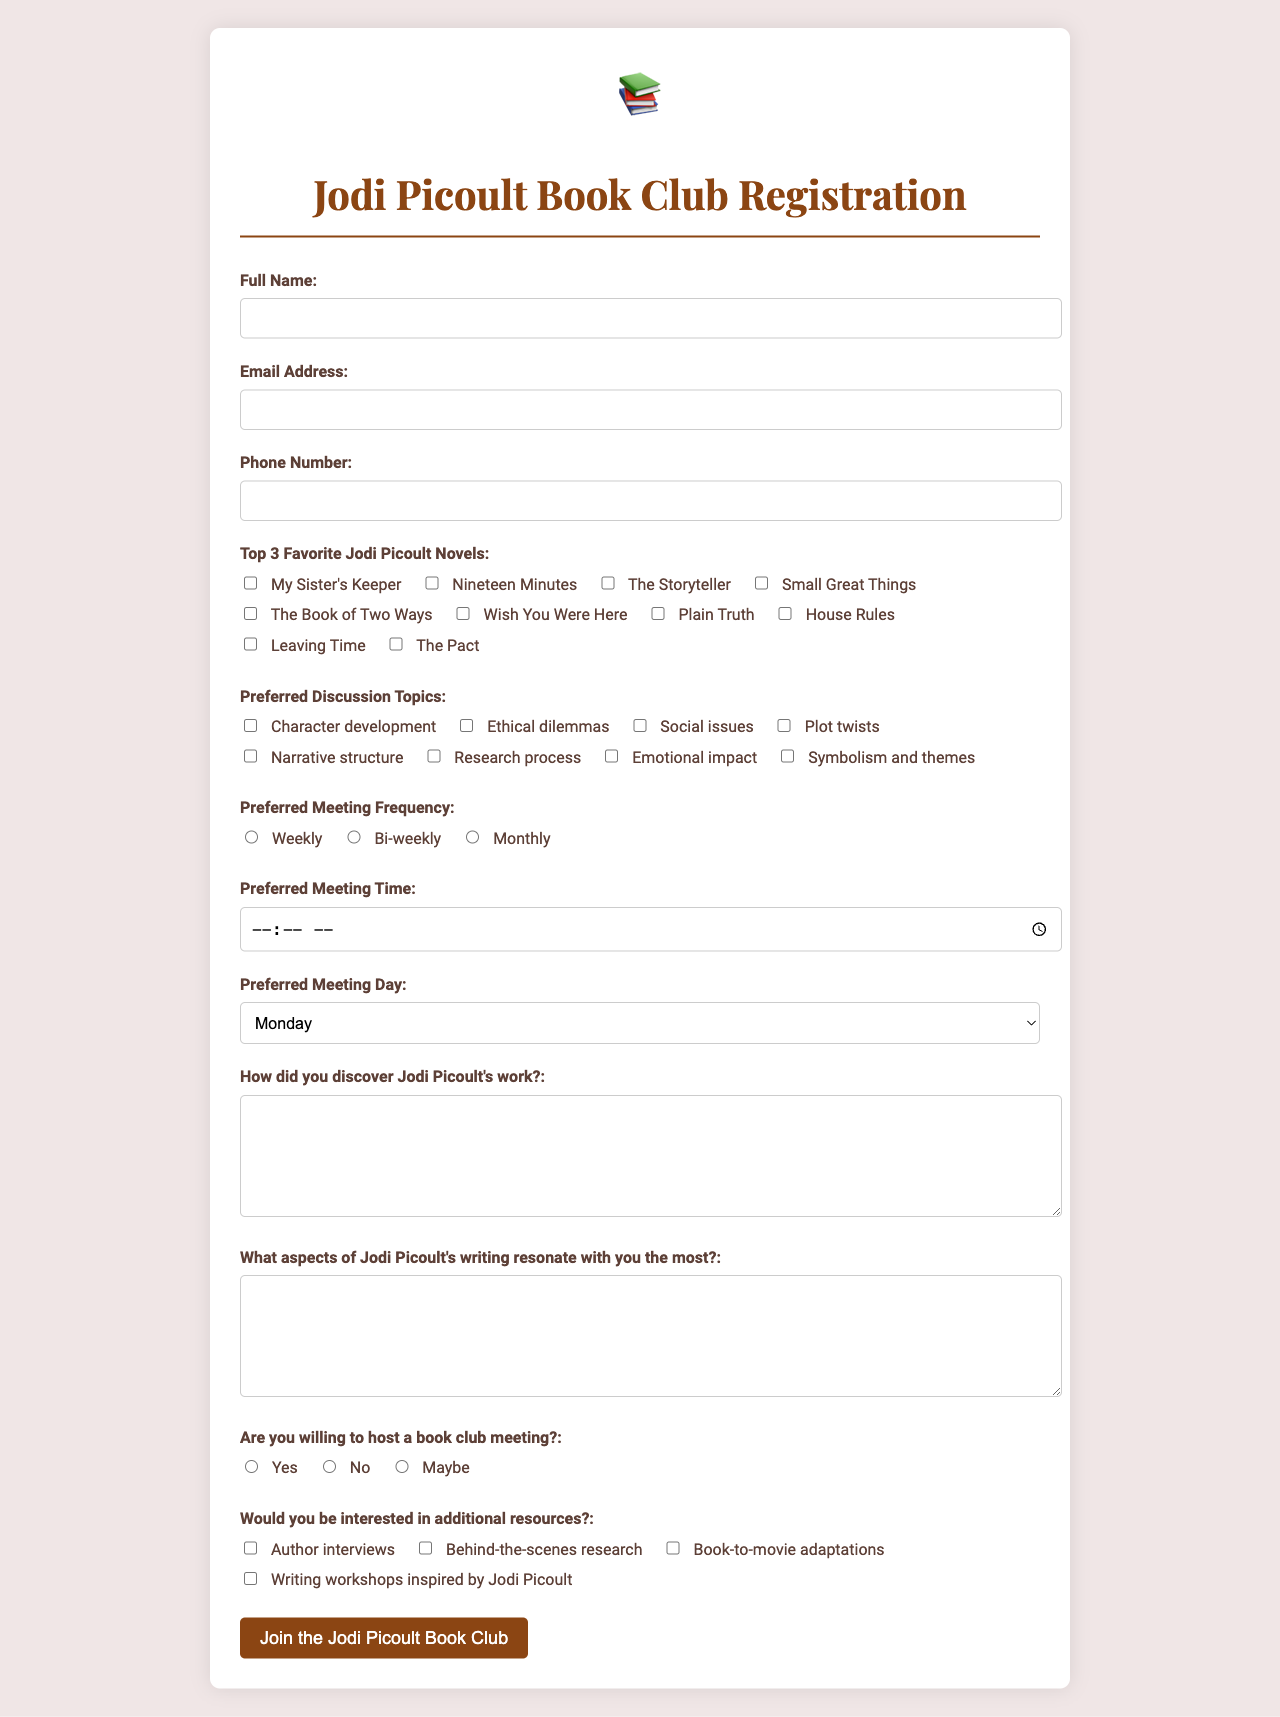what is the title of the form? The title of the form is stated at the top of the document, which indicates the purpose of the registration.
Answer: Jodi Picoult Book Club Registration how many favorite novels can be selected? The document specifies a limit on the number of selections for favorite novels, indicating a maximum choice allowed.
Answer: 3 what type of input is required for the email address? The email address field specifies a particular type of input format that users must follow when entering their information.
Answer: email what are the options for preferred meeting frequency? The document offers a selection of options that participants can choose from regarding how often they would like to meet.
Answer: Weekly, Bi-weekly, Monthly are participants required to provide a phone number? The registration form indicates whether providing a phone number is mandatory for participants or not.
Answer: No which novel is NOT listed as a favorite option? The question seeks to identify one specific novel that is absent from the provided list of favorite novels.
Answer: The Storyteller what is the form's submission button text? The text on the submission button indicates the action participants will take to complete their registration.
Answer: Join the Jodi Picoult Book Club which day can participants select for meetings? The document lists specific days participants can choose from for scheduling their meetings.
Answer: Monday, Tuesday, Wednesday, Thursday, Friday, Saturday, Sunday what are the topics available for discussion? The document includes a variety of themes that can be discussed during book club meetings, highlighting the focus topics.
Answer: Character development, Ethical dilemmas, Social issues, Plot twists, Narrative structure, Research process, Emotional impact, Symbolism and themes 